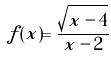Convert formula to latex. <formula><loc_0><loc_0><loc_500><loc_500>f ( x ) = \frac { \sqrt { x - 4 } } { x - 2 }</formula> 